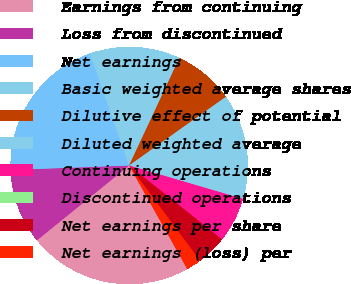<chart> <loc_0><loc_0><loc_500><loc_500><pie_chart><fcel>Earnings from continuing<fcel>Loss from discontinued<fcel>Net earnings<fcel>Basic weighted average shares<fcel>Dilutive effect of potential<fcel>Diluted weighted average<fcel>Continuing operations<fcel>Discontinued operations<fcel>Net earnings per share<fcel>Net earnings (loss) per<nl><fcel>22.29%<fcel>10.26%<fcel>20.24%<fcel>12.32%<fcel>8.21%<fcel>14.37%<fcel>6.16%<fcel>0.0%<fcel>4.11%<fcel>2.05%<nl></chart> 